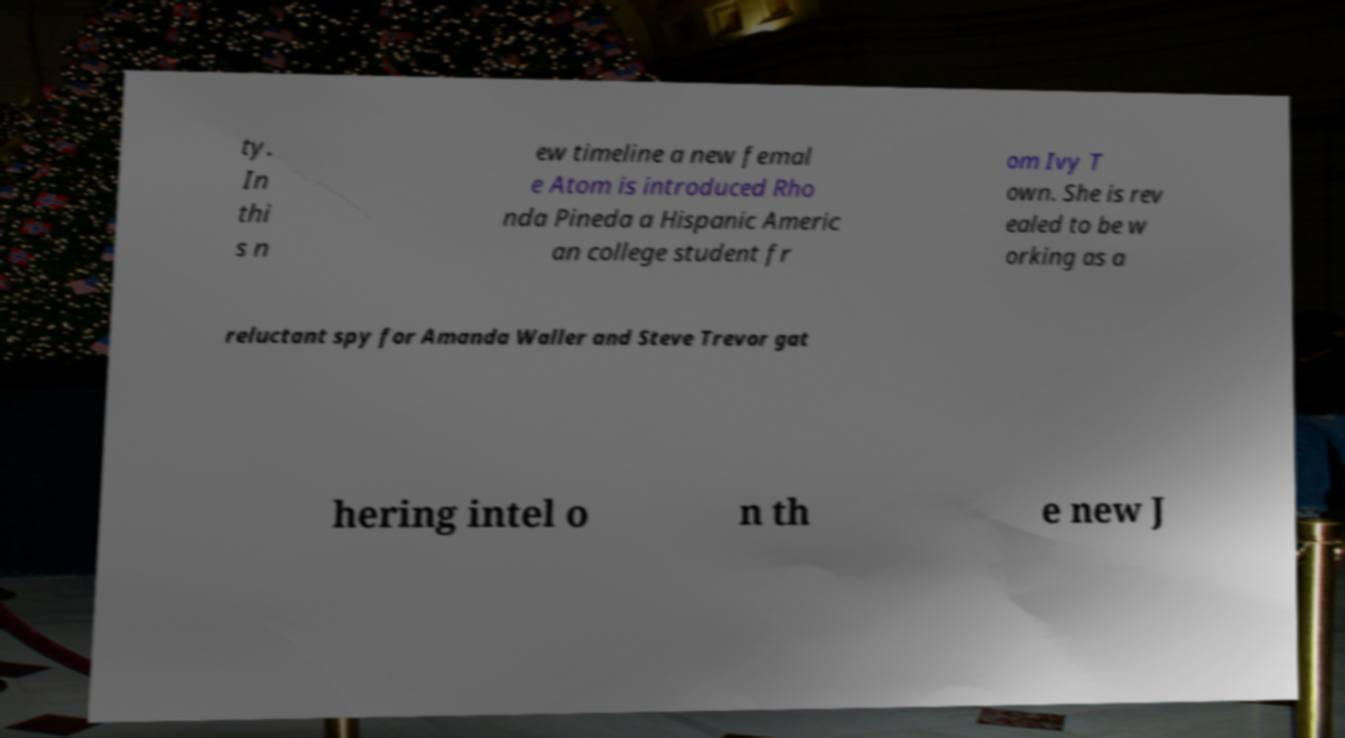Can you read and provide the text displayed in the image?This photo seems to have some interesting text. Can you extract and type it out for me? ty. In thi s n ew timeline a new femal e Atom is introduced Rho nda Pineda a Hispanic Americ an college student fr om Ivy T own. She is rev ealed to be w orking as a reluctant spy for Amanda Waller and Steve Trevor gat hering intel o n th e new J 